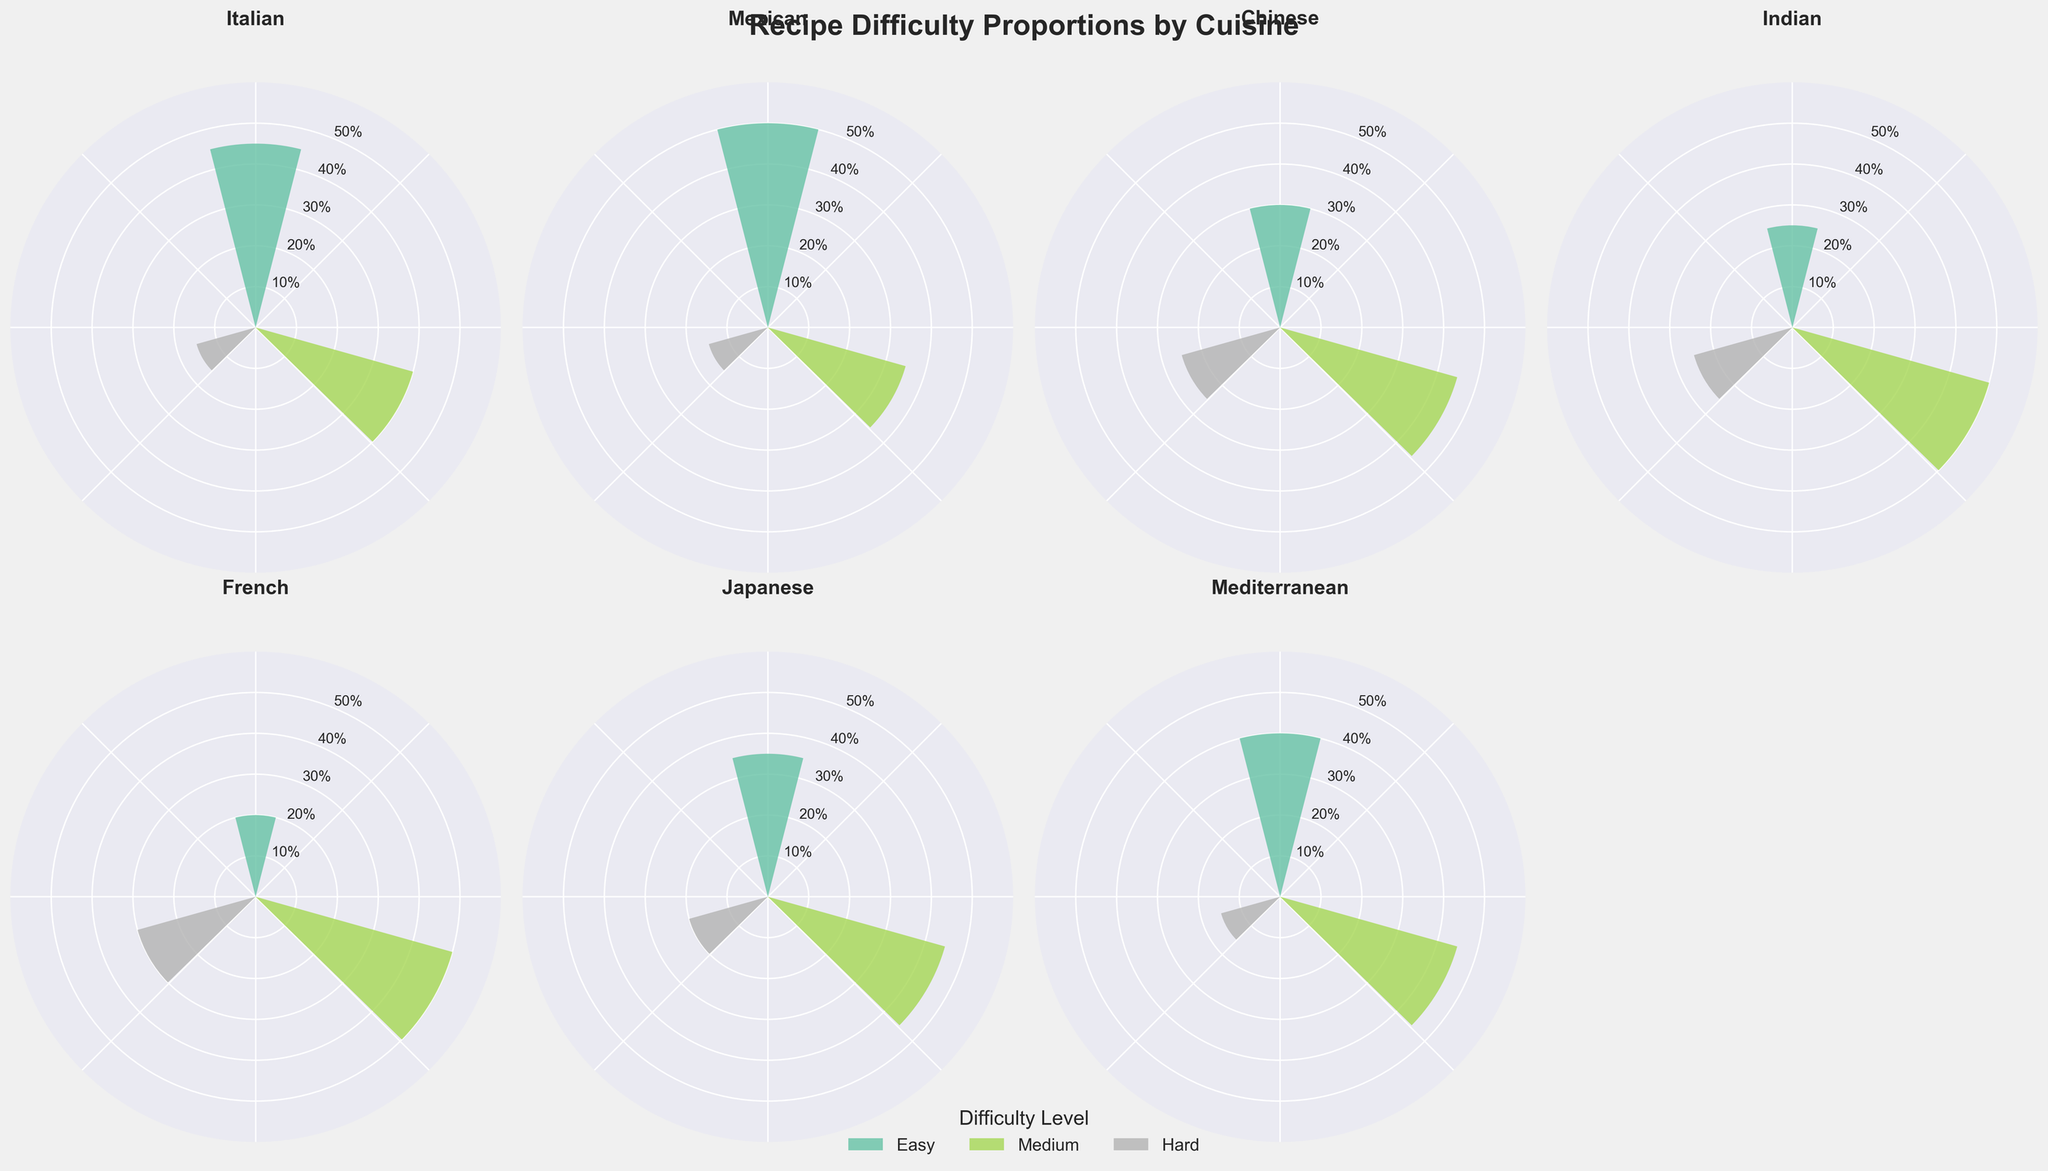What's the title of the figure? The title of the figure is usually located at the top of the chart. In this case, it is written in bold font and larger size than other text elements.
Answer: Recipe Difficulty Proportions by Cuisine Which cuisine has the highest proportion of easy recipes? To determine which cuisine has the highest proportion of easy recipes, locate the segments labeled "Easy" in each subplot. Then identify the one with the highest value on the radial axis.
Answer: Mexican What is the combined proportion of medium and hard recipes in French cuisine? First, locate the French cuisine subplot. Note the proportions of Medium and Hard recipes (0.50 and 0.30, respectively). Add these values together: 0.50 + 0.30.
Answer: 0.80 Which cuisines have an equal proportion of hard recipes? To find the cuisines with equal proportions for hard recipes, compare the values of hard recipes across the subplots. Identify the cuisines where the proportions are the same.
Answer: Chinese, Indian Is the proportion of easy recipes in Chinese cuisine greater than the proportion of medium recipes in Mediterranean cuisine? Compare the proportion of easy recipes in Chinese (0.30) with the proportion of medium recipes in Mediterranean (0.45). Check if 0.30 is greater than 0.45.
Answer: No What is the difference in the proportion of hard recipes between Indian and Japanese cuisines? Find the proportions of hard recipes for both Indian (0.25) and Japanese (0.20) cuisines. Subtract the Japanese proportion from the Indian: 0.25 - 0.20.
Answer: 0.05 How many cuisines have a medium recipe proportion greater than 0.40? Identify the subplots where the proportion value for Medium is greater than 0.40. Count these cuisines.
Answer: 5 Which difficulty level has the highest average proportion across all cuisines? Calculate the average proportion for each difficulty level by adding up all proportions for that level across cuisines and dividing by the number of cuisines (7). Compare the averages to determine the highest.
Answer: Medium What is the proportion difference between the easiest and hardest recipes in Italian cuisine? For the Italian cuisine, find the proportions for Easy (0.45) and Hard (0.15). Subtract the Hard proportion from the Easy: 0.45 - 0.15.
Answer: 0.30 